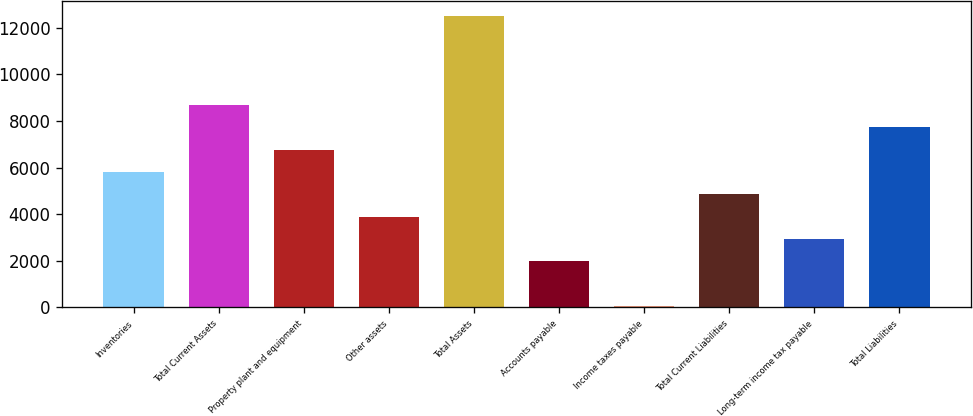<chart> <loc_0><loc_0><loc_500><loc_500><bar_chart><fcel>Inventories<fcel>Total Current Assets<fcel>Property plant and equipment<fcel>Other assets<fcel>Total Assets<fcel>Accounts payable<fcel>Income taxes payable<fcel>Total Current Liabilities<fcel>Long-term income tax payable<fcel>Total Liabilities<nl><fcel>5809.78<fcel>8678.47<fcel>6766.01<fcel>3897.32<fcel>12503.4<fcel>1984.86<fcel>72.4<fcel>4853.55<fcel>2941.09<fcel>7722.24<nl></chart> 